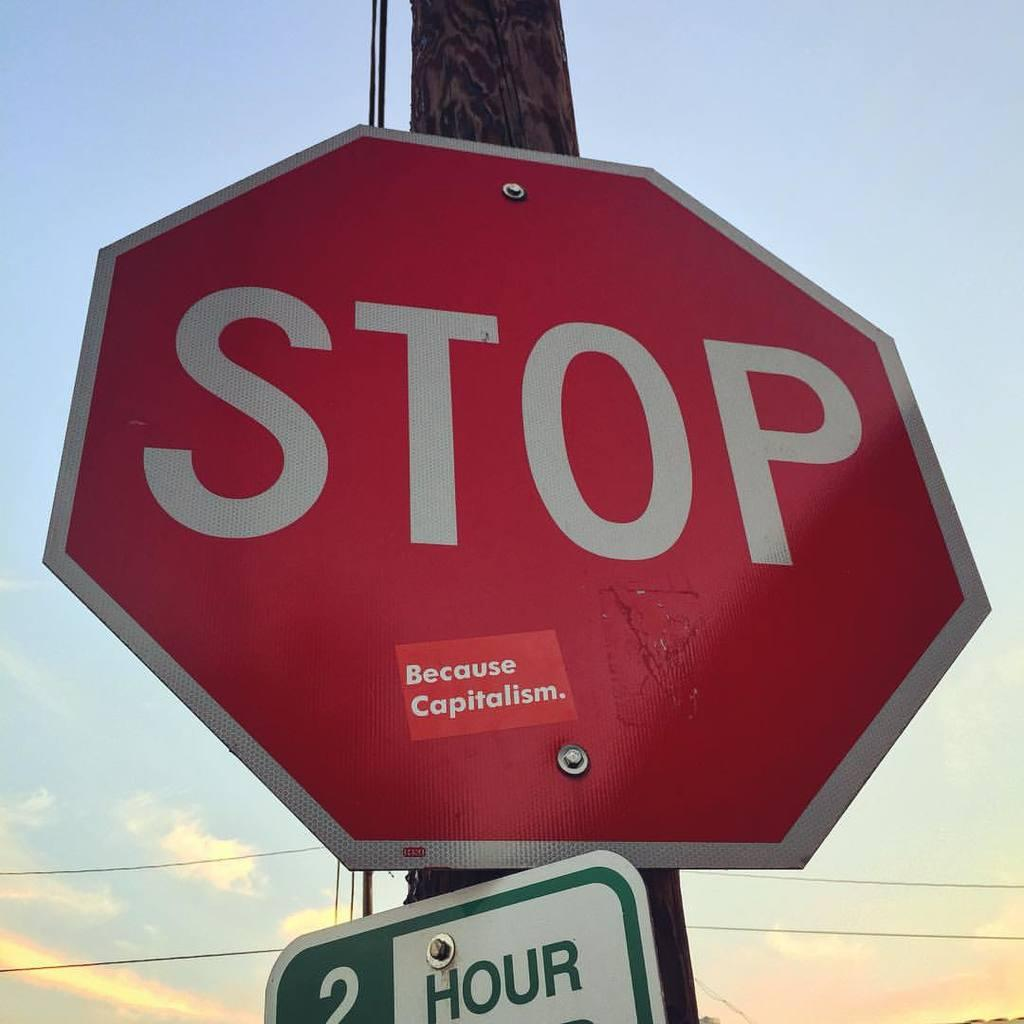<image>
Give a short and clear explanation of the subsequent image. a stop sign that is located above a 2 hour sign 